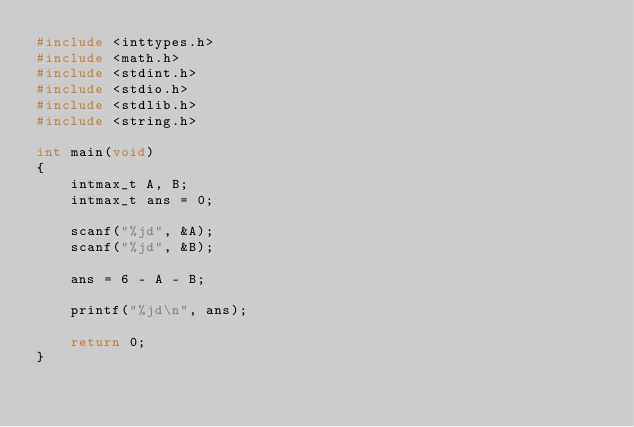<code> <loc_0><loc_0><loc_500><loc_500><_C_>#include <inttypes.h>
#include <math.h>
#include <stdint.h>
#include <stdio.h>
#include <stdlib.h>
#include <string.h>

int main(void)
{
    intmax_t A, B;
    intmax_t ans = 0;

    scanf("%jd", &A);
    scanf("%jd", &B);

    ans = 6 - A - B;

    printf("%jd\n", ans);

    return 0;
}
</code> 